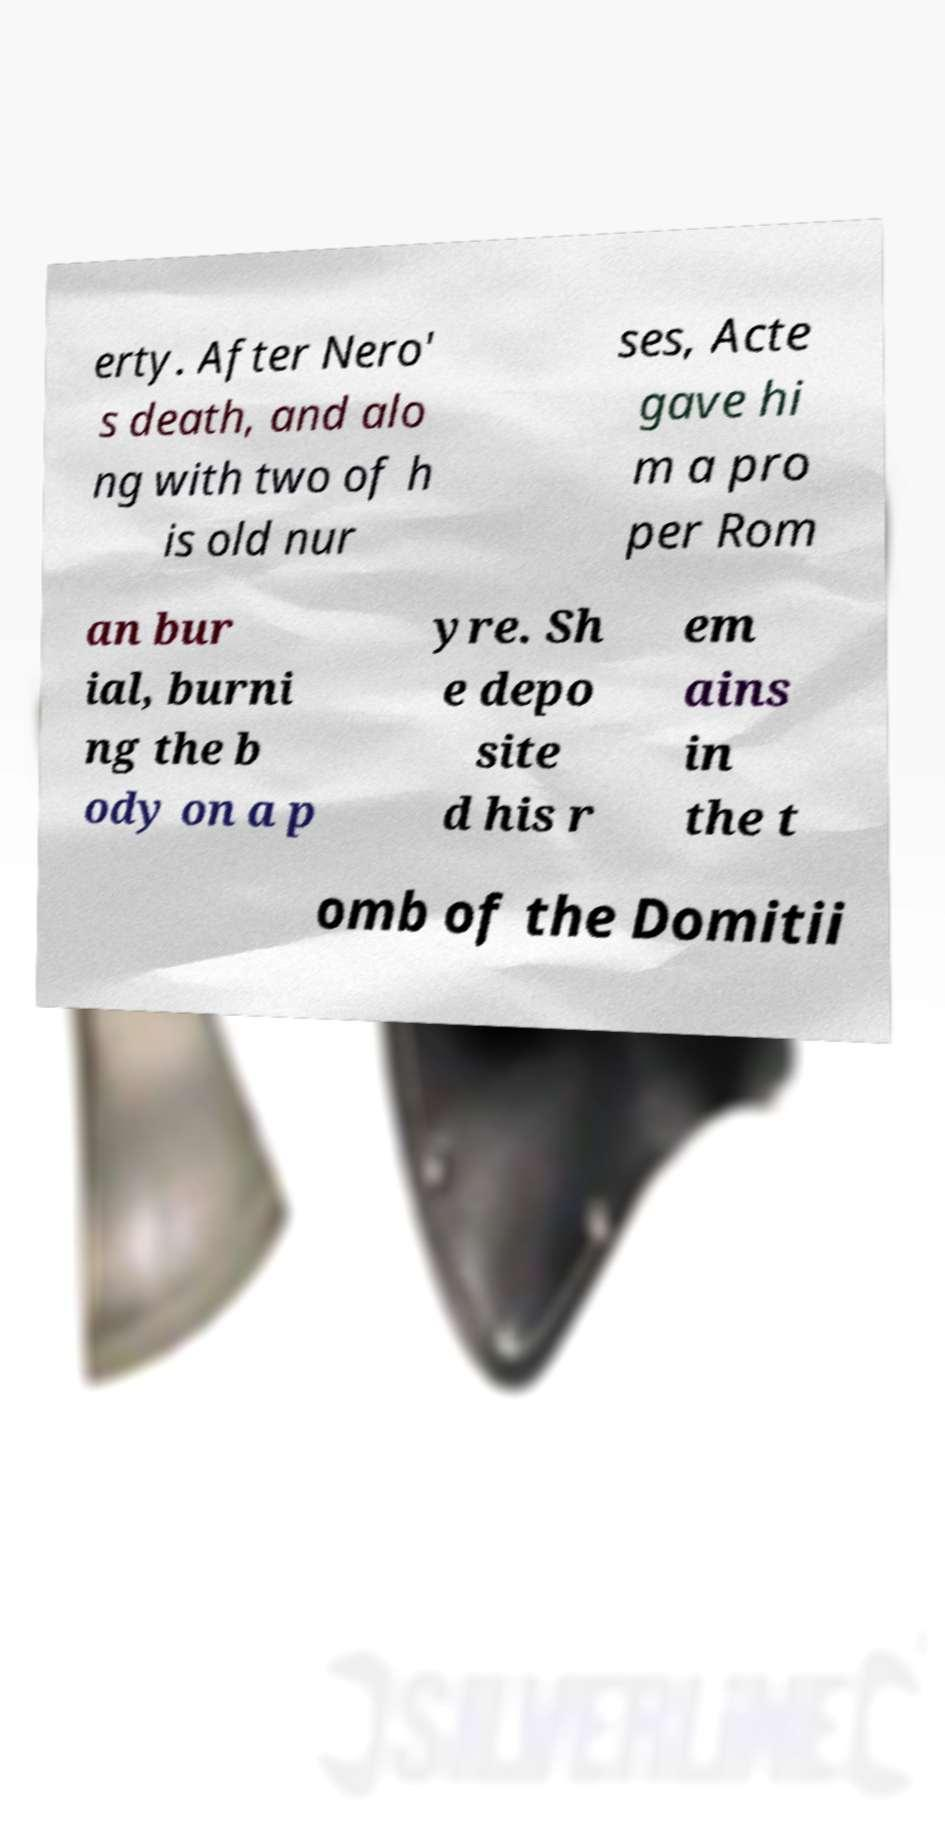There's text embedded in this image that I need extracted. Can you transcribe it verbatim? erty. After Nero' s death, and alo ng with two of h is old nur ses, Acte gave hi m a pro per Rom an bur ial, burni ng the b ody on a p yre. Sh e depo site d his r em ains in the t omb of the Domitii 